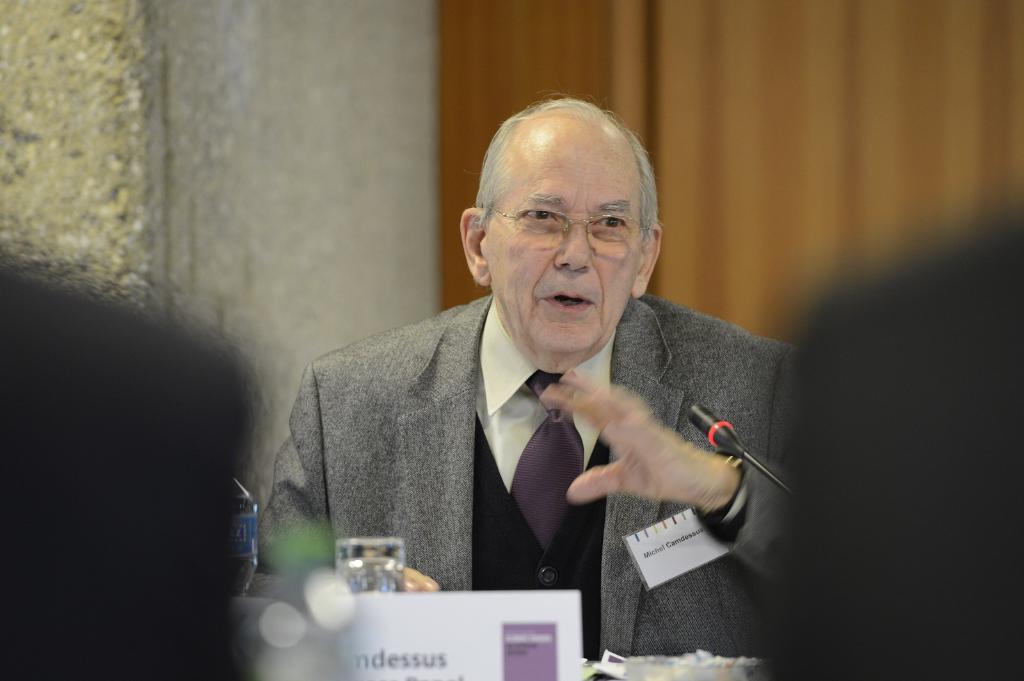Is the man speaking young in age?
Give a very brief answer. Answering does not require reading text in the image. What is the last latter in the name?
Your response must be concise. S. 